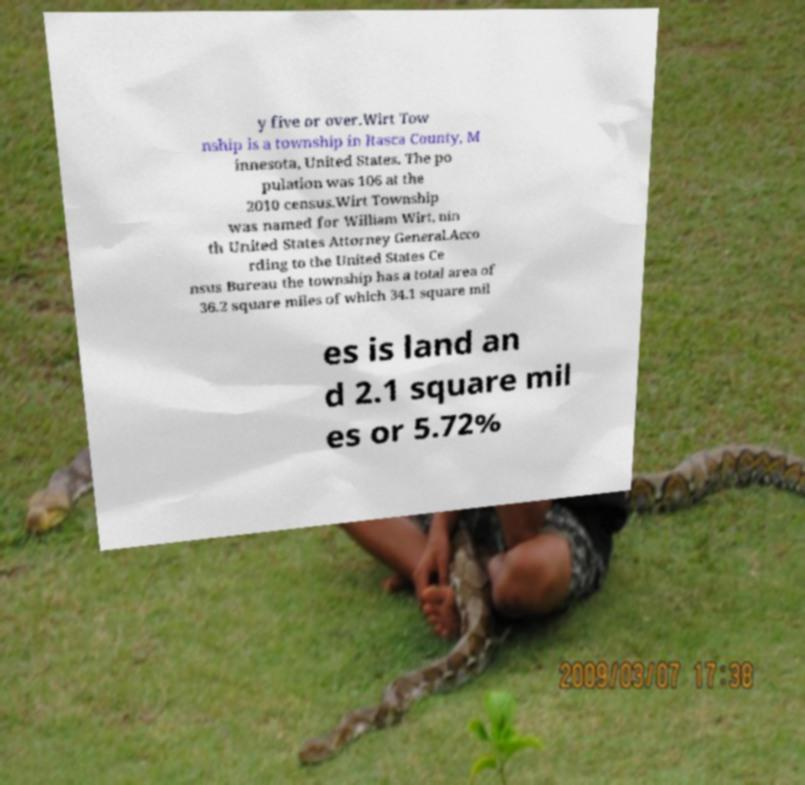Can you read and provide the text displayed in the image?This photo seems to have some interesting text. Can you extract and type it out for me? y five or over.Wirt Tow nship is a township in Itasca County, M innesota, United States. The po pulation was 106 at the 2010 census.Wirt Township was named for William Wirt, nin th United States Attorney General.Acco rding to the United States Ce nsus Bureau the township has a total area of 36.2 square miles of which 34.1 square mil es is land an d 2.1 square mil es or 5.72% 